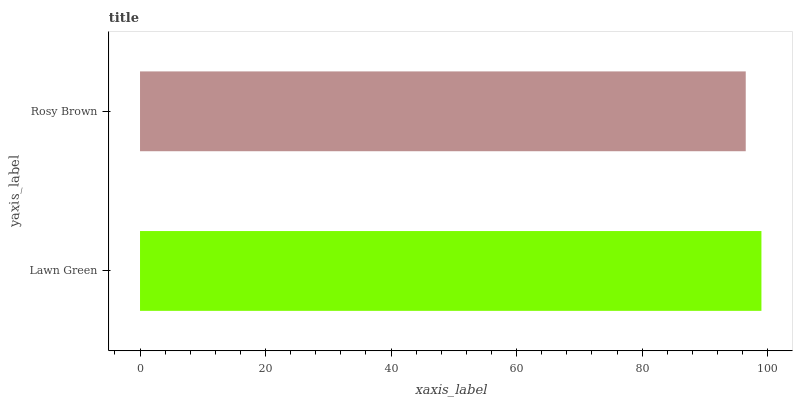Is Rosy Brown the minimum?
Answer yes or no. Yes. Is Lawn Green the maximum?
Answer yes or no. Yes. Is Rosy Brown the maximum?
Answer yes or no. No. Is Lawn Green greater than Rosy Brown?
Answer yes or no. Yes. Is Rosy Brown less than Lawn Green?
Answer yes or no. Yes. Is Rosy Brown greater than Lawn Green?
Answer yes or no. No. Is Lawn Green less than Rosy Brown?
Answer yes or no. No. Is Lawn Green the high median?
Answer yes or no. Yes. Is Rosy Brown the low median?
Answer yes or no. Yes. Is Rosy Brown the high median?
Answer yes or no. No. Is Lawn Green the low median?
Answer yes or no. No. 